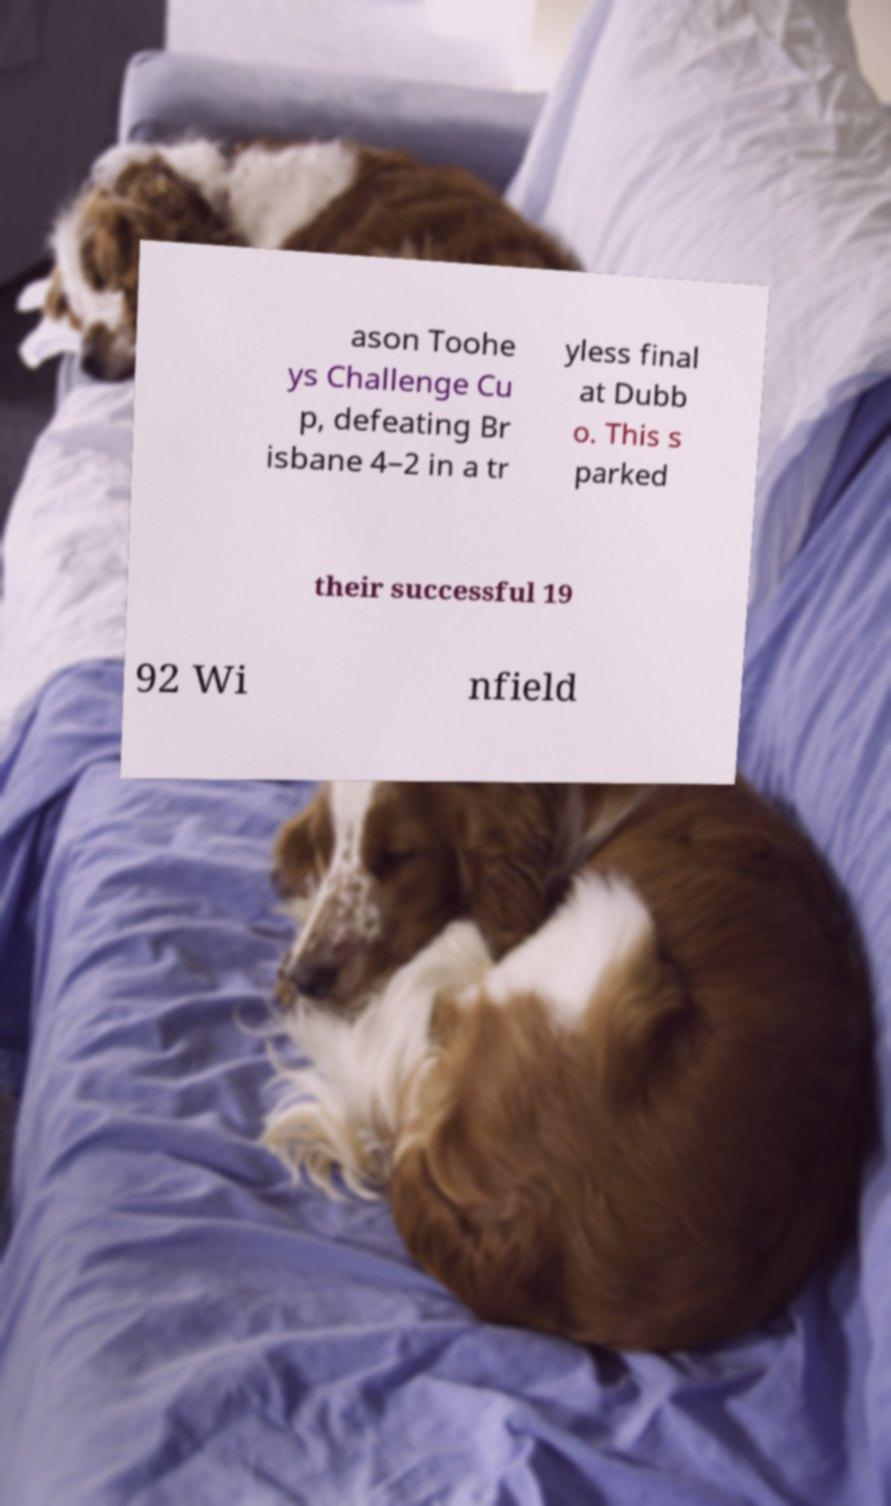I need the written content from this picture converted into text. Can you do that? ason Toohe ys Challenge Cu p, defeating Br isbane 4–2 in a tr yless final at Dubb o. This s parked their successful 19 92 Wi nfield 